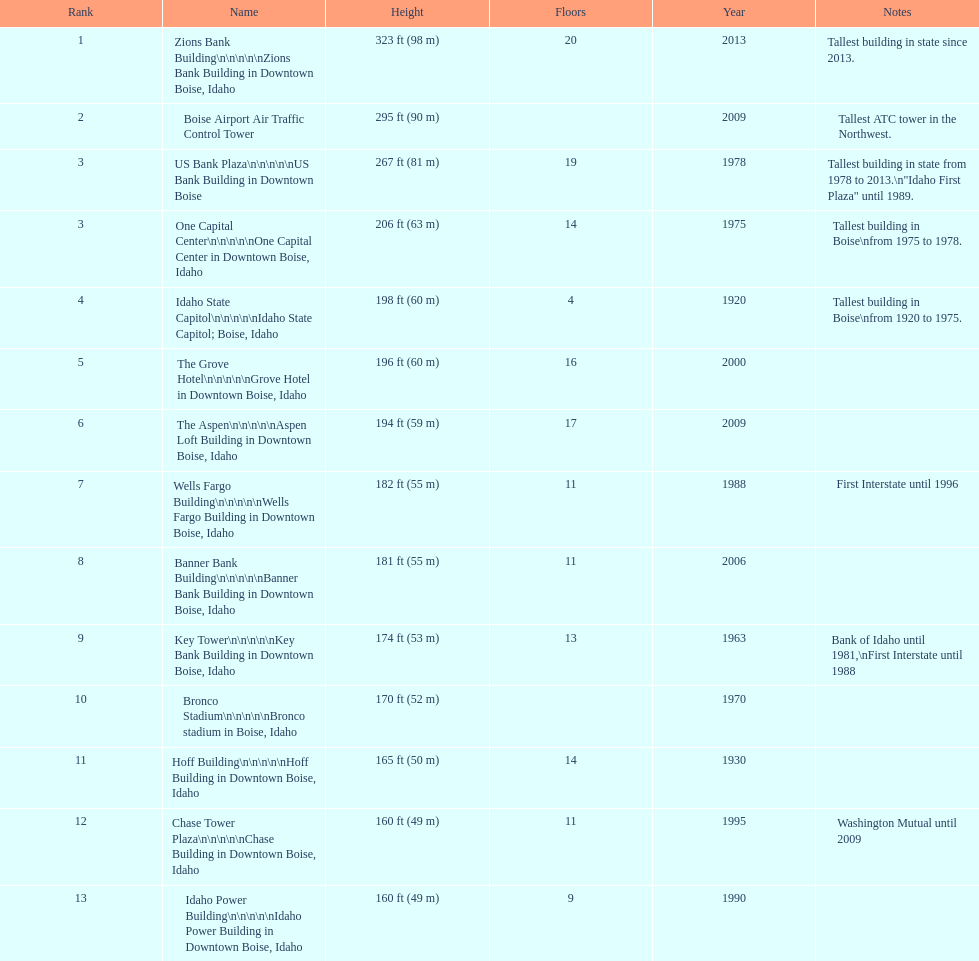How many of these structures were constructed after 1975? 8. 